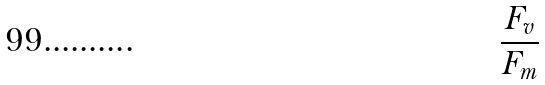<formula> <loc_0><loc_0><loc_500><loc_500>\frac { F _ { v } } { F _ { m } }</formula> 